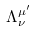<formula> <loc_0><loc_0><loc_500><loc_500>\Lambda _ { \nu } ^ { \mu ^ { \prime } }</formula> 